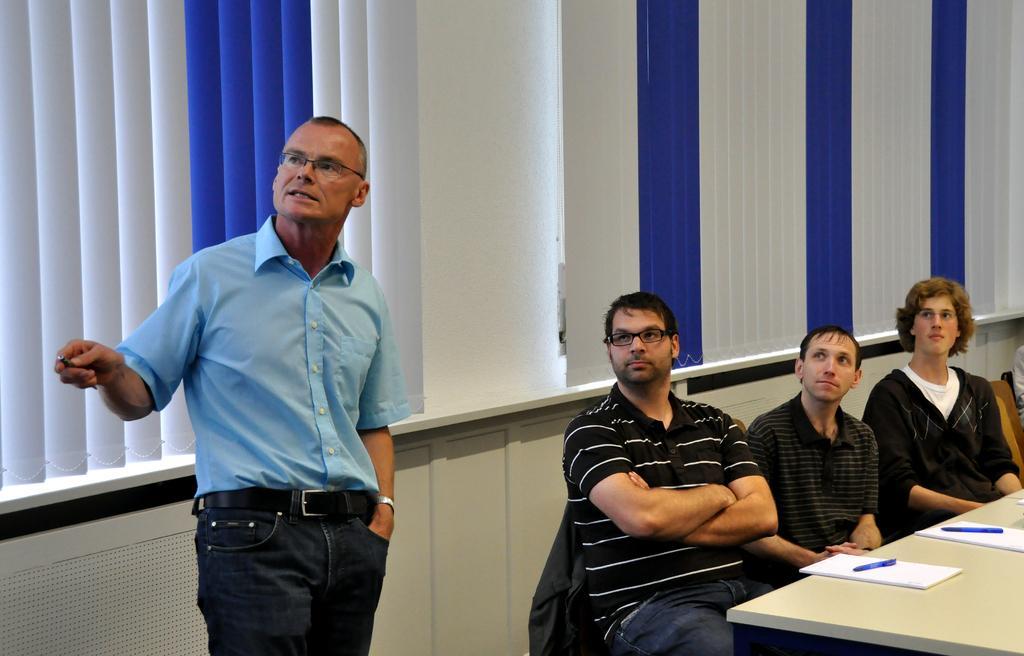How would you summarize this image in a sentence or two? In this picture there are people, among them few people sitting on chairs and we can see books and pens on the table. In the background of the image we can see window blinds and wall. 